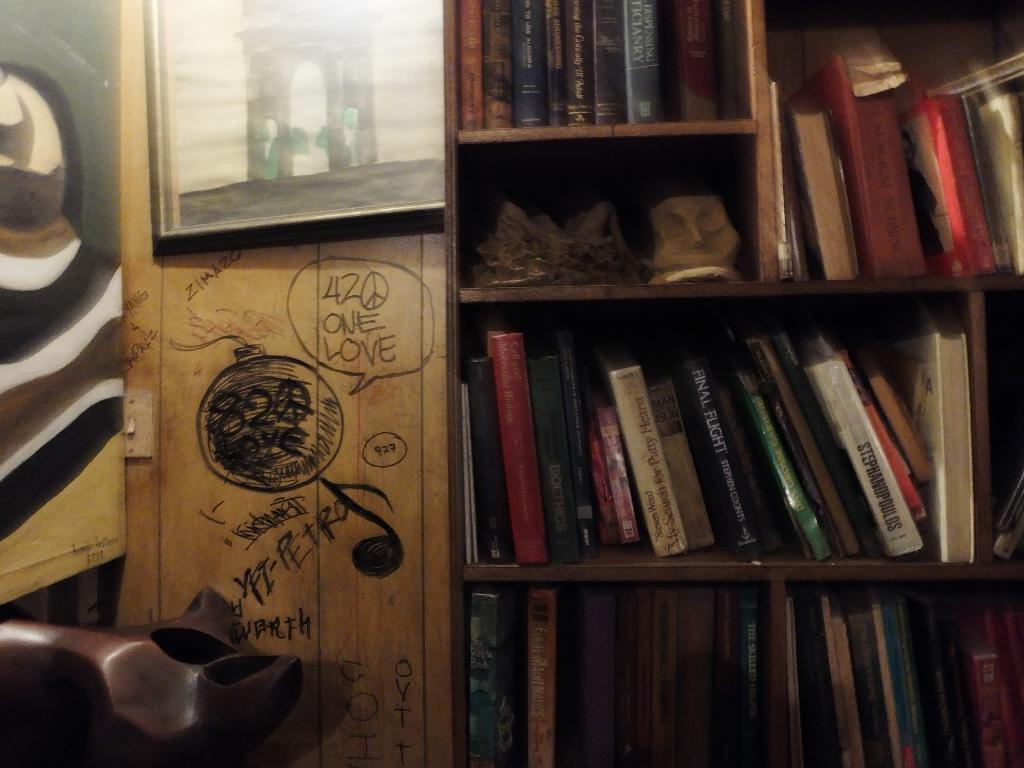What objects can be seen in the image? There are books and other things in the racks in the image. Can you describe the frame at the top of the image? There is a frame at the top of the image, but its specific details are not mentioned in the facts. What might be the purpose of the racks in the image? The racks in the image might be used for storage or displaying items, such as books and other objects. What type of news can be seen written on the chalkboard in the image? There is no chalkboard or news present in the image; it only features books and other things in the racks, along with a frame at the top. 